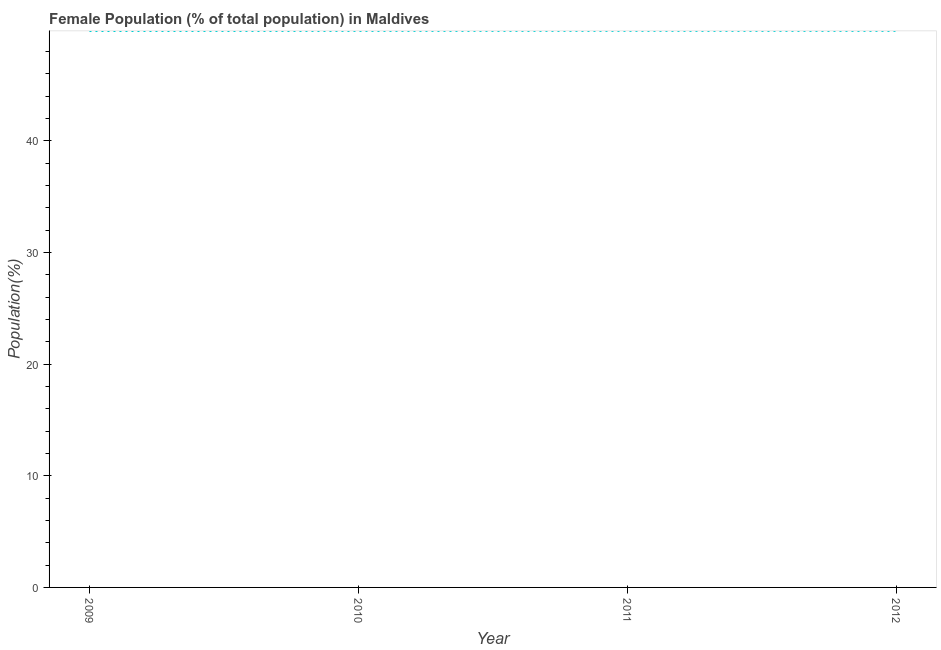What is the female population in 2010?
Make the answer very short. 49.86. Across all years, what is the maximum female population?
Your answer should be very brief. 49.86. Across all years, what is the minimum female population?
Ensure brevity in your answer.  49.85. In which year was the female population maximum?
Make the answer very short. 2011. In which year was the female population minimum?
Keep it short and to the point. 2009. What is the sum of the female population?
Your response must be concise. 199.43. What is the difference between the female population in 2009 and 2010?
Provide a succinct answer. -0.01. What is the average female population per year?
Your answer should be very brief. 49.86. What is the median female population?
Your answer should be compact. 49.86. Do a majority of the years between 2010 and 2011 (inclusive) have female population greater than 32 %?
Your answer should be compact. Yes. What is the ratio of the female population in 2010 to that in 2012?
Provide a short and direct response. 1. What is the difference between the highest and the second highest female population?
Offer a very short reply. 0. What is the difference between the highest and the lowest female population?
Provide a short and direct response. 0.02. How many years are there in the graph?
Give a very brief answer. 4. What is the difference between two consecutive major ticks on the Y-axis?
Provide a short and direct response. 10. Does the graph contain any zero values?
Ensure brevity in your answer.  No. What is the title of the graph?
Your response must be concise. Female Population (% of total population) in Maldives. What is the label or title of the X-axis?
Offer a very short reply. Year. What is the label or title of the Y-axis?
Ensure brevity in your answer.  Population(%). What is the Population(%) in 2009?
Keep it short and to the point. 49.85. What is the Population(%) in 2010?
Your response must be concise. 49.86. What is the Population(%) in 2011?
Ensure brevity in your answer.  49.86. What is the Population(%) of 2012?
Make the answer very short. 49.86. What is the difference between the Population(%) in 2009 and 2010?
Your response must be concise. -0.01. What is the difference between the Population(%) in 2009 and 2011?
Keep it short and to the point. -0.02. What is the difference between the Population(%) in 2009 and 2012?
Provide a short and direct response. -0.02. What is the difference between the Population(%) in 2010 and 2011?
Ensure brevity in your answer.  -0.01. What is the difference between the Population(%) in 2010 and 2012?
Offer a terse response. -0. What is the difference between the Population(%) in 2011 and 2012?
Provide a short and direct response. 0. What is the ratio of the Population(%) in 2009 to that in 2010?
Your response must be concise. 1. What is the ratio of the Population(%) in 2009 to that in 2012?
Your answer should be very brief. 1. What is the ratio of the Population(%) in 2010 to that in 2011?
Offer a very short reply. 1. What is the ratio of the Population(%) in 2010 to that in 2012?
Your answer should be compact. 1. What is the ratio of the Population(%) in 2011 to that in 2012?
Offer a very short reply. 1. 